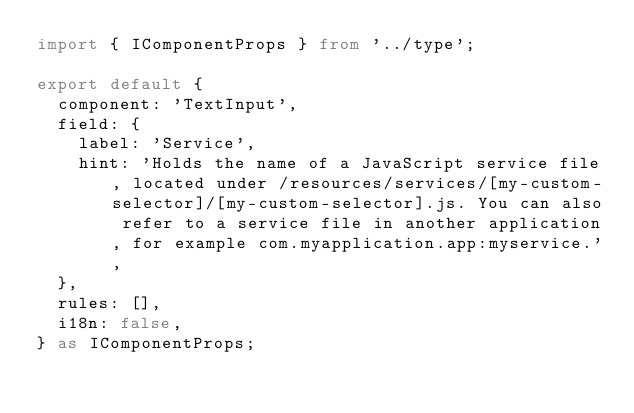<code> <loc_0><loc_0><loc_500><loc_500><_TypeScript_>import { IComponentProps } from '../type';

export default {
  component: 'TextInput',
  field: {
    label: 'Service',
    hint: 'Holds the name of a JavaScript service file, located under /resources/services/[my-custom-selector]/[my-custom-selector].js. You can also refer to a service file in another application, for example com.myapplication.app:myservice.',
  },
  rules: [],
  i18n: false,
} as IComponentProps;
</code> 